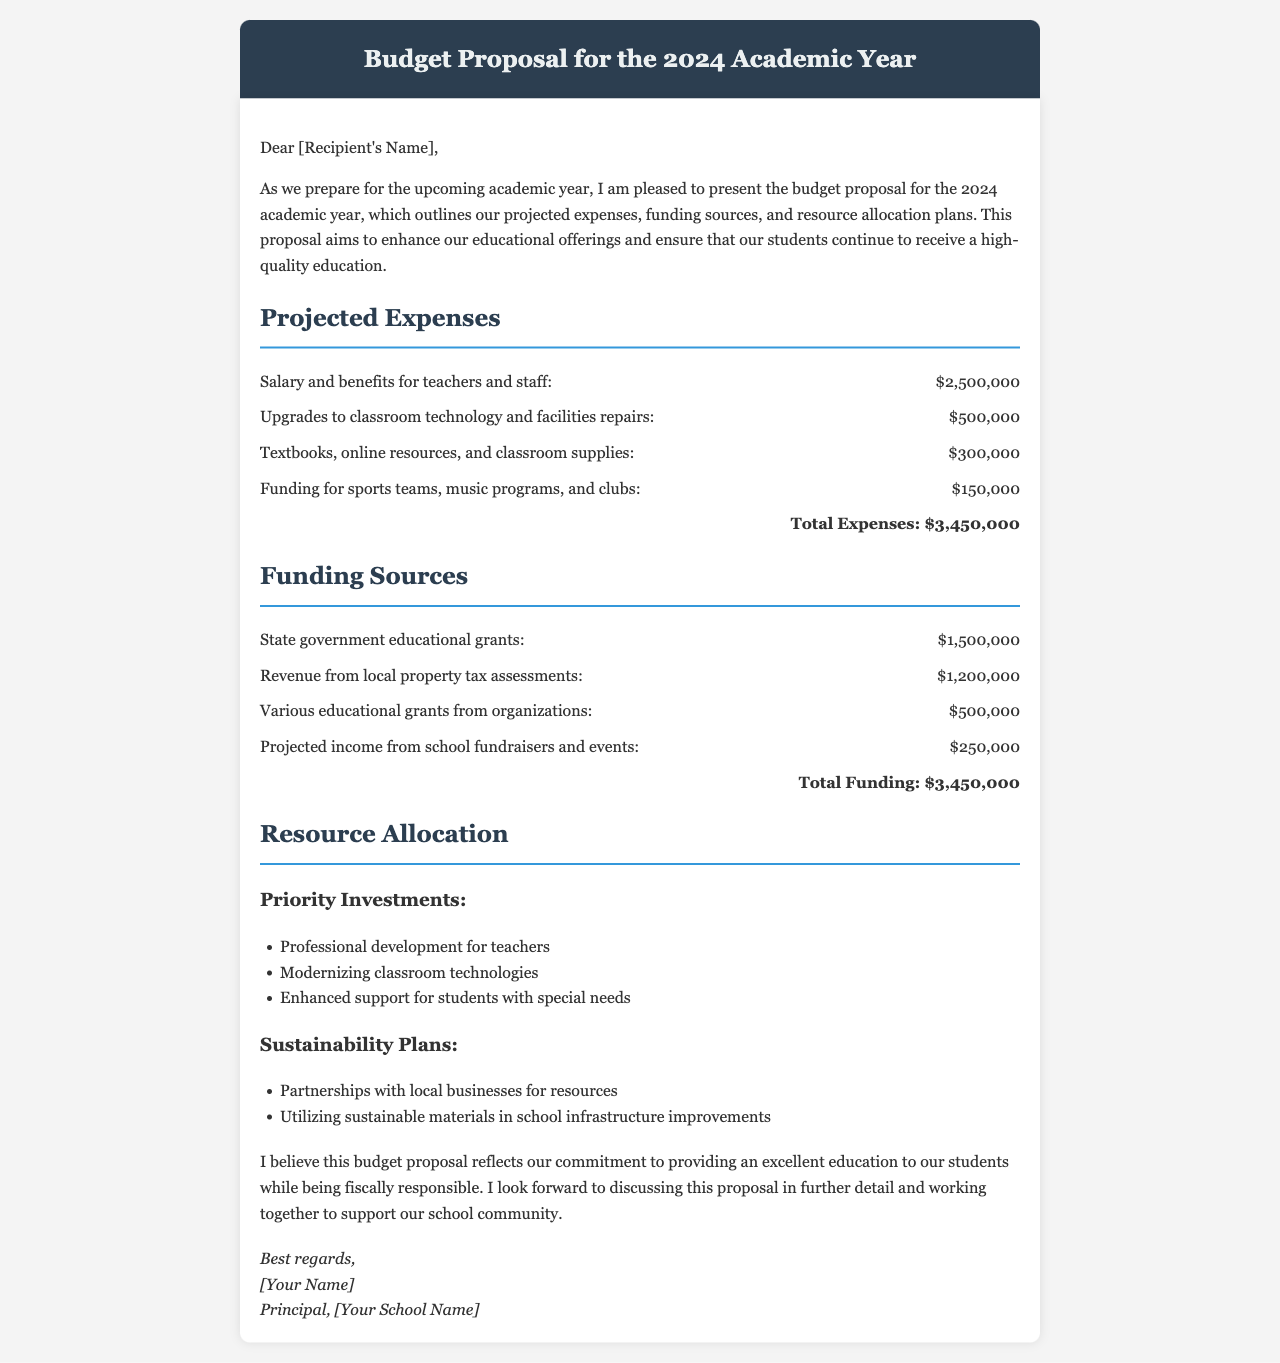What is the total expense for the academic year? The total expenses are clearly stated at the bottom of the projected expenses section of the document.
Answer: $3,450,000 What are the funding sources mentioned? The funding sources include several specific entities that contribute to the budget, as outlined in the funding sources section.
Answer: State government educational grants, Revenue from local property tax assessments, Various educational grants from organizations, Projected income from school fundraisers and events What is allocated for upgrading classroom technology and facilities repairs? The specific expense amount for this item can be found in the projected expenses section.
Answer: $500,000 What is the total funding amount? The total funding is presented at the end of the funding sources section, summarizing all funding sources together.
Answer: $3,450,000 What is one of the priority investments mentioned in resource allocation? The resource allocation section lists specific investments prioritized for the academic year.
Answer: Professional development for teachers How much is allocated for funding sports teams, music programs, and clubs? The amount allocated for these activities is specified in the projected expenses section.
Answer: $150,000 What is the proposed amount from school fundraisers and events? The projected income from school fundraisers and events is detailed in the funding sources section.
Answer: $250,000 What is the document's main purpose? The primary intention of the document is outlined in the introductory paragraph.
Answer: Budget proposal for the 2024 academic year 